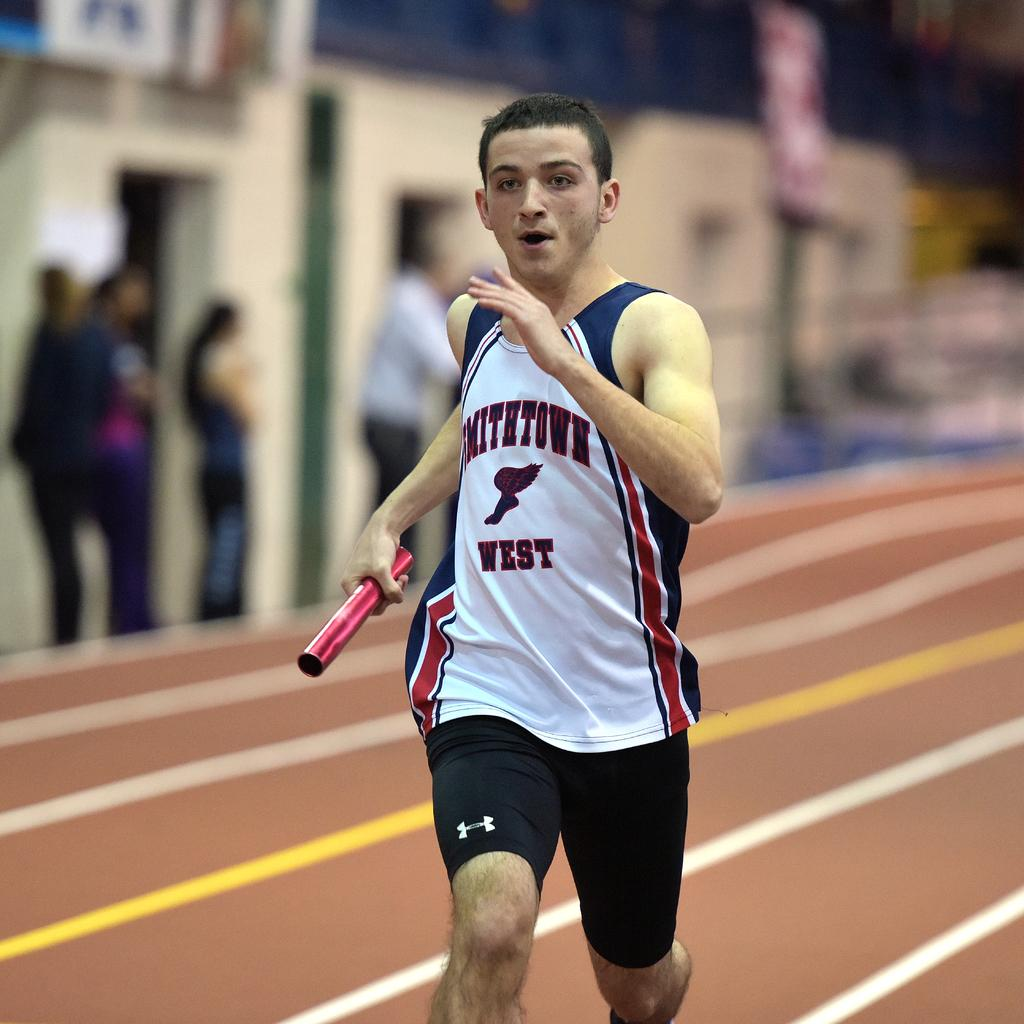<image>
Share a concise interpretation of the image provided. A runner on the track wearing jersey from Smithtown West. 